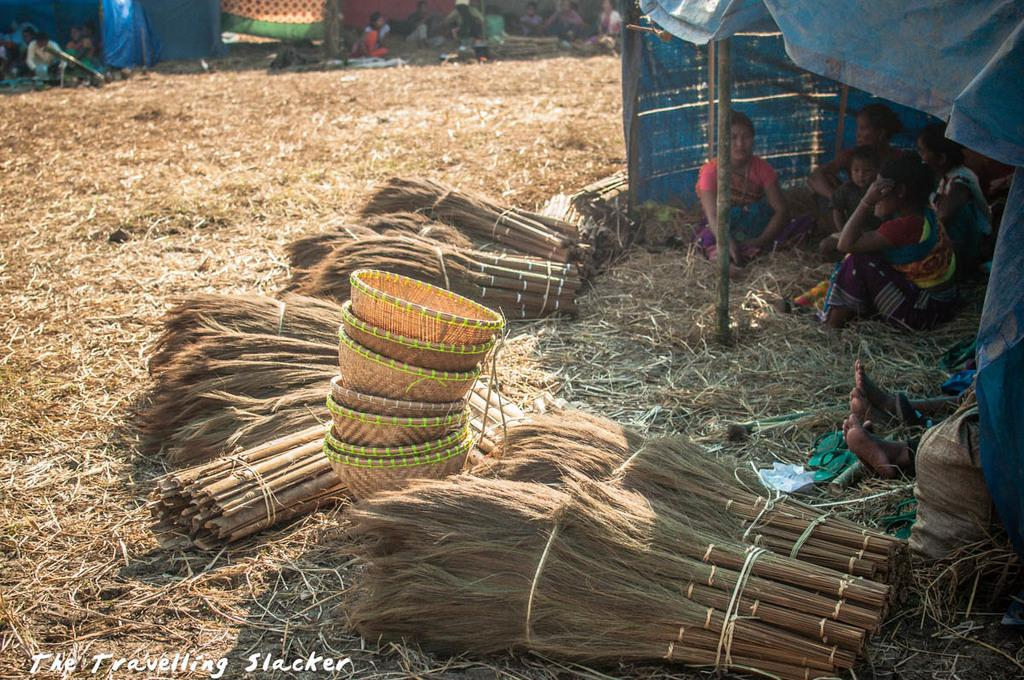What can be seen in the image involving a group of people? There is a group of people in the image. What type of temporary shelter is present in the image? There are tents in the image. What objects are used for carrying or holding items in the image? Groom sticks and baskets are visible in the image. Where is the text located in the image? There is some text in the bottom left corner of the image. What item is on the right side of the image? There is a bag on the right side of the image. What type of drum can be heard playing in the image? There is no drum present in the image, and therefore no sound can be heard. What type of print is visible on the bag in the image? There is no print visible on the bag in the image; it is not mentioned in the provided facts. 